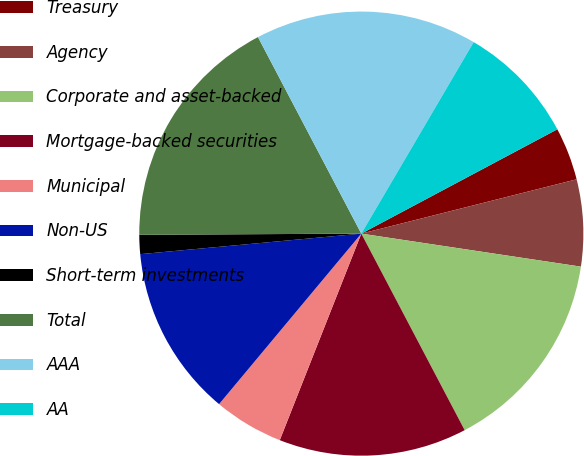<chart> <loc_0><loc_0><loc_500><loc_500><pie_chart><fcel>Treasury<fcel>Agency<fcel>Corporate and asset-backed<fcel>Mortgage-backed securities<fcel>Municipal<fcel>Non-US<fcel>Short-term investments<fcel>Total<fcel>AAA<fcel>AA<nl><fcel>3.85%<fcel>6.31%<fcel>14.92%<fcel>13.69%<fcel>5.08%<fcel>12.46%<fcel>1.39%<fcel>17.38%<fcel>16.15%<fcel>8.77%<nl></chart> 